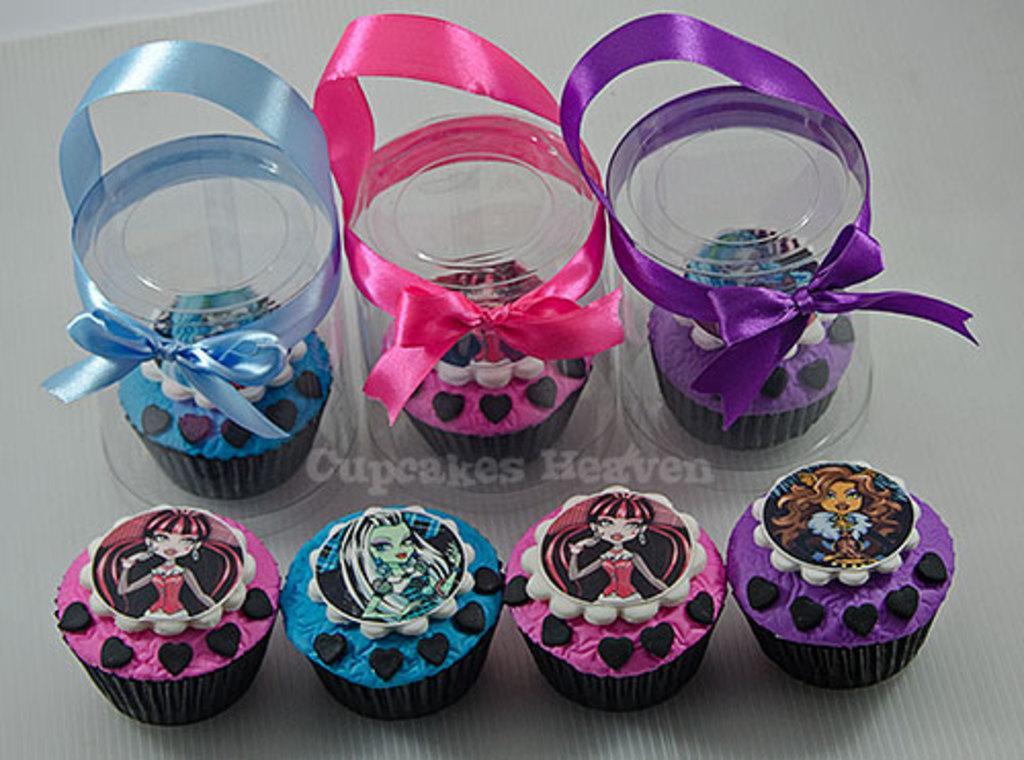Please provide a concise description of this image. In this image there are muffins, ribbons and jars kept on the gray surface. Inside the jar there are muffins. On the muffins there are cartoon pictures. In the middle of the image there is a watermark.   